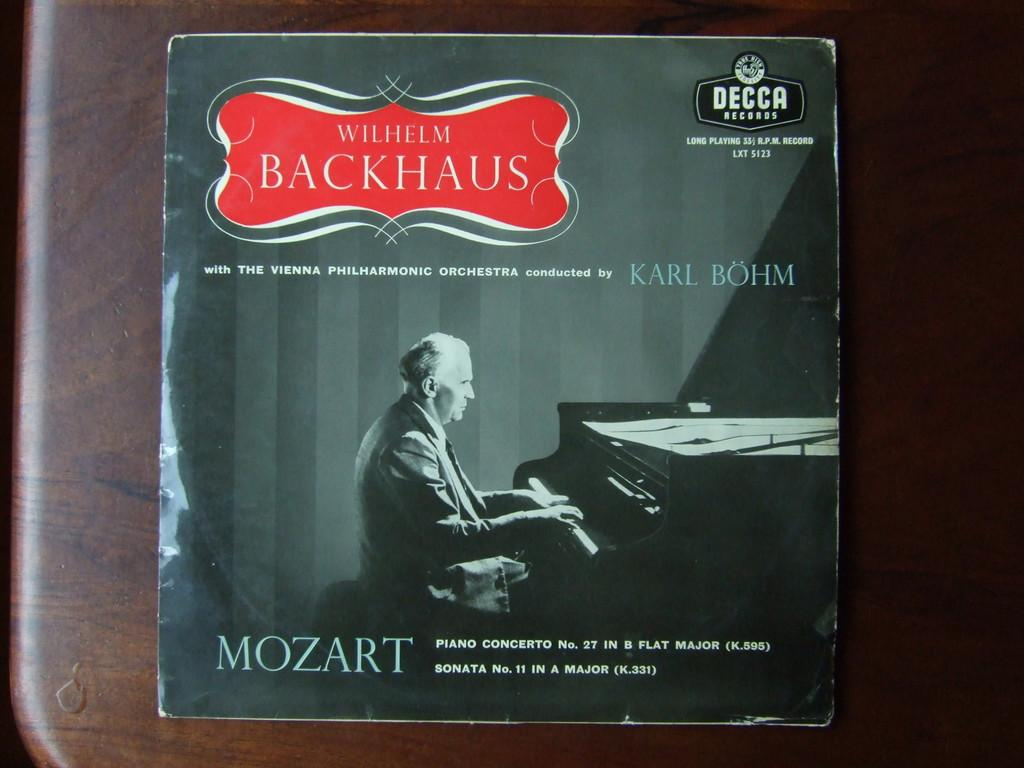<image>
Describe the image concisely. A cover for a Wilhelm Blackhaus Mozart concert. 